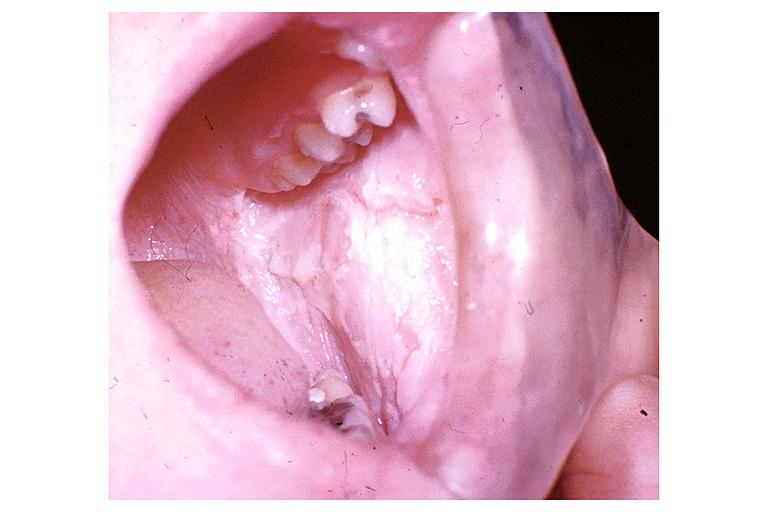s oral present?
Answer the question using a single word or phrase. Yes 